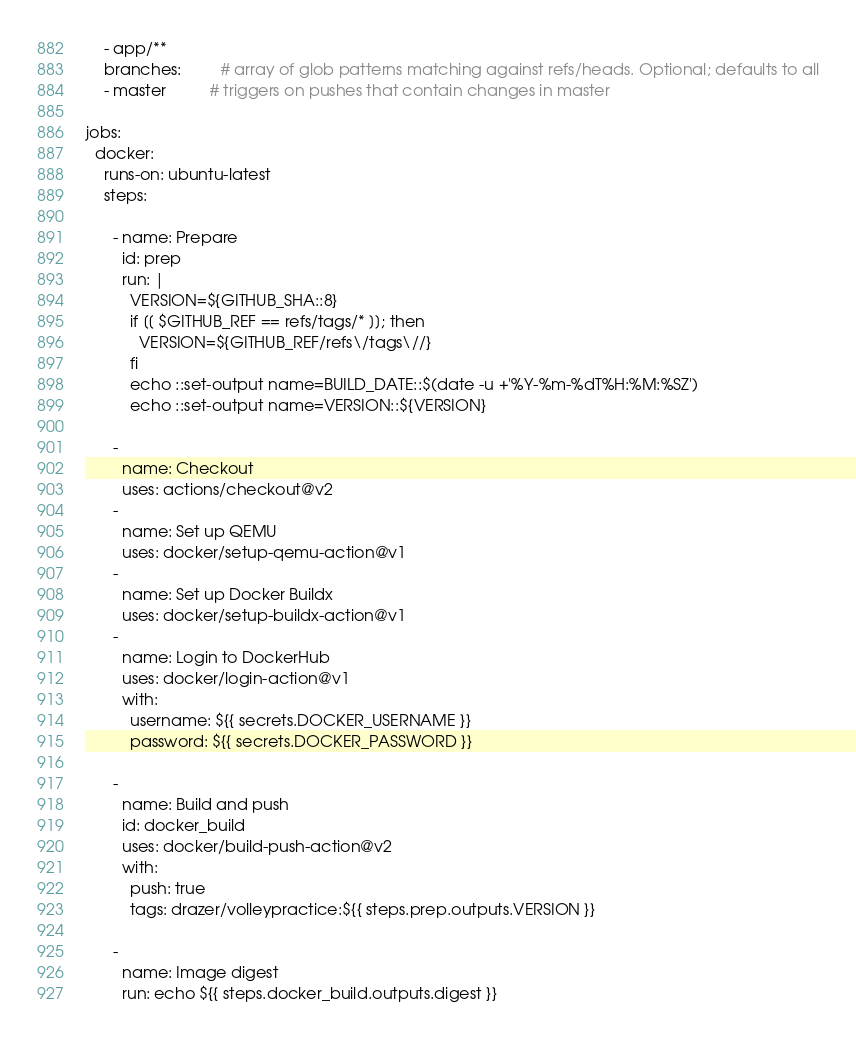Convert code to text. <code><loc_0><loc_0><loc_500><loc_500><_YAML_>    - app/**
    branches:         # array of glob patterns matching against refs/heads. Optional; defaults to all
    - master          # triggers on pushes that contain changes in master
   
jobs:
  docker:
    runs-on: ubuntu-latest
    steps:
    
      - name: Prepare
        id: prep
        run: |
          VERSION=${GITHUB_SHA::8}
          if [[ $GITHUB_REF == refs/tags/* ]]; then
            VERSION=${GITHUB_REF/refs\/tags\//}
          fi
          echo ::set-output name=BUILD_DATE::$(date -u +'%Y-%m-%dT%H:%M:%SZ')
          echo ::set-output name=VERSION::${VERSION}    
    
      -
        name: Checkout
        uses: actions/checkout@v2
      -
        name: Set up QEMU
        uses: docker/setup-qemu-action@v1
      -
        name: Set up Docker Buildx
        uses: docker/setup-buildx-action@v1
      -
        name: Login to DockerHub
        uses: docker/login-action@v1
        with:
          username: ${{ secrets.DOCKER_USERNAME }}
          password: ${{ secrets.DOCKER_PASSWORD }}
          
      - 
        name: Build and push
        id: docker_build
        uses: docker/build-push-action@v2
        with:
          push: true
          tags: drazer/volleypractice:${{ steps.prep.outputs.VERSION }}

      - 
        name: Image digest
        run: echo ${{ steps.docker_build.outputs.digest }}
</code> 